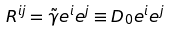<formula> <loc_0><loc_0><loc_500><loc_500>R ^ { i j } = \tilde { \gamma } e ^ { i } e ^ { j } \equiv D _ { 0 } e ^ { i } e ^ { j }</formula> 